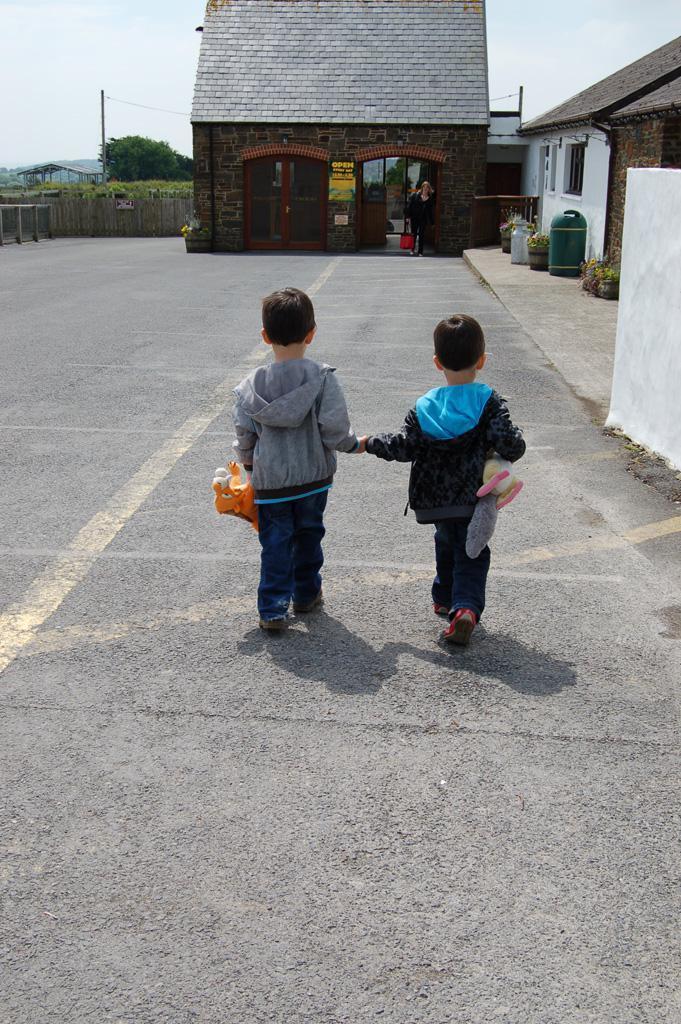Can you describe this image briefly? In this image we can see the two kids holding the toys and walking on the road. In the background we can see the houses, trash bin, flower pots, fencing wall, barrier and also the trees. We can also see the poles with the wires. Sky is also visible in this image. We can also see a person standing. 